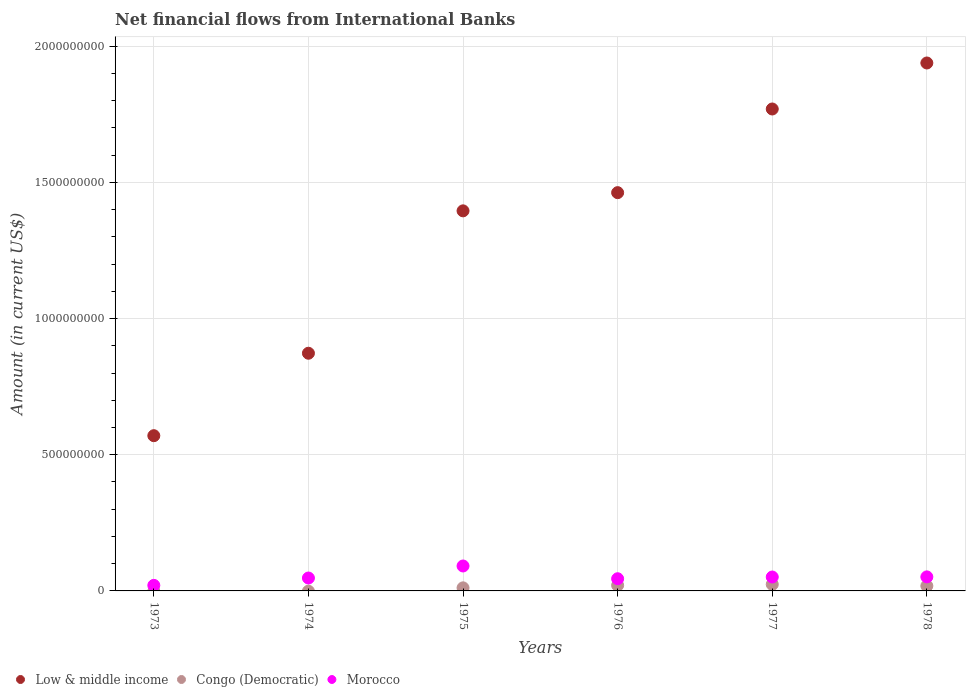Is the number of dotlines equal to the number of legend labels?
Make the answer very short. No. What is the net financial aid flows in Low & middle income in 1975?
Keep it short and to the point. 1.40e+09. Across all years, what is the maximum net financial aid flows in Low & middle income?
Keep it short and to the point. 1.94e+09. Across all years, what is the minimum net financial aid flows in Low & middle income?
Your response must be concise. 5.70e+08. In which year was the net financial aid flows in Morocco maximum?
Offer a very short reply. 1975. What is the total net financial aid flows in Congo (Democratic) in the graph?
Make the answer very short. 7.43e+07. What is the difference between the net financial aid flows in Morocco in 1974 and that in 1975?
Give a very brief answer. -4.42e+07. What is the difference between the net financial aid flows in Low & middle income in 1976 and the net financial aid flows in Congo (Democratic) in 1974?
Your answer should be very brief. 1.46e+09. What is the average net financial aid flows in Morocco per year?
Ensure brevity in your answer.  5.11e+07. In the year 1976, what is the difference between the net financial aid flows in Congo (Democratic) and net financial aid flows in Low & middle income?
Offer a terse response. -1.44e+09. In how many years, is the net financial aid flows in Low & middle income greater than 700000000 US$?
Keep it short and to the point. 5. What is the ratio of the net financial aid flows in Congo (Democratic) in 1975 to that in 1976?
Ensure brevity in your answer.  0.55. Is the net financial aid flows in Morocco in 1973 less than that in 1974?
Make the answer very short. Yes. Is the difference between the net financial aid flows in Congo (Democratic) in 1975 and 1977 greater than the difference between the net financial aid flows in Low & middle income in 1975 and 1977?
Your answer should be compact. Yes. What is the difference between the highest and the second highest net financial aid flows in Morocco?
Offer a very short reply. 4.00e+07. What is the difference between the highest and the lowest net financial aid flows in Morocco?
Your response must be concise. 7.12e+07. In how many years, is the net financial aid flows in Congo (Democratic) greater than the average net financial aid flows in Congo (Democratic) taken over all years?
Keep it short and to the point. 3. Is the sum of the net financial aid flows in Morocco in 1973 and 1977 greater than the maximum net financial aid flows in Low & middle income across all years?
Provide a short and direct response. No. Is the net financial aid flows in Congo (Democratic) strictly less than the net financial aid flows in Low & middle income over the years?
Give a very brief answer. Yes. How many years are there in the graph?
Keep it short and to the point. 6. What is the difference between two consecutive major ticks on the Y-axis?
Provide a short and direct response. 5.00e+08. Are the values on the major ticks of Y-axis written in scientific E-notation?
Offer a terse response. No. How are the legend labels stacked?
Your answer should be very brief. Horizontal. What is the title of the graph?
Offer a terse response. Net financial flows from International Banks. Does "Grenada" appear as one of the legend labels in the graph?
Keep it short and to the point. No. What is the label or title of the X-axis?
Provide a succinct answer. Years. What is the label or title of the Y-axis?
Provide a succinct answer. Amount (in current US$). What is the Amount (in current US$) of Low & middle income in 1973?
Offer a terse response. 5.70e+08. What is the Amount (in current US$) in Congo (Democratic) in 1973?
Your answer should be compact. 0. What is the Amount (in current US$) of Morocco in 1973?
Provide a succinct answer. 2.04e+07. What is the Amount (in current US$) of Low & middle income in 1974?
Make the answer very short. 8.73e+08. What is the Amount (in current US$) in Morocco in 1974?
Offer a terse response. 4.74e+07. What is the Amount (in current US$) of Low & middle income in 1975?
Keep it short and to the point. 1.40e+09. What is the Amount (in current US$) of Congo (Democratic) in 1975?
Your answer should be very brief. 1.13e+07. What is the Amount (in current US$) in Morocco in 1975?
Offer a terse response. 9.16e+07. What is the Amount (in current US$) of Low & middle income in 1976?
Your answer should be compact. 1.46e+09. What is the Amount (in current US$) of Congo (Democratic) in 1976?
Make the answer very short. 2.06e+07. What is the Amount (in current US$) of Morocco in 1976?
Offer a very short reply. 4.47e+07. What is the Amount (in current US$) in Low & middle income in 1977?
Offer a terse response. 1.77e+09. What is the Amount (in current US$) of Congo (Democratic) in 1977?
Offer a very short reply. 2.40e+07. What is the Amount (in current US$) in Morocco in 1977?
Provide a succinct answer. 5.11e+07. What is the Amount (in current US$) of Low & middle income in 1978?
Provide a short and direct response. 1.94e+09. What is the Amount (in current US$) of Congo (Democratic) in 1978?
Your response must be concise. 1.85e+07. What is the Amount (in current US$) of Morocco in 1978?
Keep it short and to the point. 5.15e+07. Across all years, what is the maximum Amount (in current US$) of Low & middle income?
Your answer should be compact. 1.94e+09. Across all years, what is the maximum Amount (in current US$) in Congo (Democratic)?
Keep it short and to the point. 2.40e+07. Across all years, what is the maximum Amount (in current US$) in Morocco?
Offer a very short reply. 9.16e+07. Across all years, what is the minimum Amount (in current US$) in Low & middle income?
Make the answer very short. 5.70e+08. Across all years, what is the minimum Amount (in current US$) in Congo (Democratic)?
Your response must be concise. 0. Across all years, what is the minimum Amount (in current US$) in Morocco?
Your answer should be compact. 2.04e+07. What is the total Amount (in current US$) in Low & middle income in the graph?
Provide a short and direct response. 8.01e+09. What is the total Amount (in current US$) in Congo (Democratic) in the graph?
Provide a succinct answer. 7.43e+07. What is the total Amount (in current US$) in Morocco in the graph?
Provide a short and direct response. 3.07e+08. What is the difference between the Amount (in current US$) of Low & middle income in 1973 and that in 1974?
Provide a short and direct response. -3.03e+08. What is the difference between the Amount (in current US$) of Morocco in 1973 and that in 1974?
Make the answer very short. -2.70e+07. What is the difference between the Amount (in current US$) in Low & middle income in 1973 and that in 1975?
Offer a very short reply. -8.26e+08. What is the difference between the Amount (in current US$) of Morocco in 1973 and that in 1975?
Offer a very short reply. -7.12e+07. What is the difference between the Amount (in current US$) of Low & middle income in 1973 and that in 1976?
Give a very brief answer. -8.92e+08. What is the difference between the Amount (in current US$) in Morocco in 1973 and that in 1976?
Keep it short and to the point. -2.43e+07. What is the difference between the Amount (in current US$) of Low & middle income in 1973 and that in 1977?
Ensure brevity in your answer.  -1.20e+09. What is the difference between the Amount (in current US$) of Morocco in 1973 and that in 1977?
Ensure brevity in your answer.  -3.07e+07. What is the difference between the Amount (in current US$) of Low & middle income in 1973 and that in 1978?
Provide a succinct answer. -1.37e+09. What is the difference between the Amount (in current US$) in Morocco in 1973 and that in 1978?
Offer a terse response. -3.11e+07. What is the difference between the Amount (in current US$) in Low & middle income in 1974 and that in 1975?
Ensure brevity in your answer.  -5.23e+08. What is the difference between the Amount (in current US$) of Morocco in 1974 and that in 1975?
Keep it short and to the point. -4.42e+07. What is the difference between the Amount (in current US$) in Low & middle income in 1974 and that in 1976?
Provide a succinct answer. -5.90e+08. What is the difference between the Amount (in current US$) in Morocco in 1974 and that in 1976?
Your answer should be very brief. 2.64e+06. What is the difference between the Amount (in current US$) of Low & middle income in 1974 and that in 1977?
Ensure brevity in your answer.  -8.97e+08. What is the difference between the Amount (in current US$) of Morocco in 1974 and that in 1977?
Keep it short and to the point. -3.71e+06. What is the difference between the Amount (in current US$) in Low & middle income in 1974 and that in 1978?
Give a very brief answer. -1.07e+09. What is the difference between the Amount (in current US$) of Morocco in 1974 and that in 1978?
Offer a terse response. -4.17e+06. What is the difference between the Amount (in current US$) of Low & middle income in 1975 and that in 1976?
Your response must be concise. -6.68e+07. What is the difference between the Amount (in current US$) in Congo (Democratic) in 1975 and that in 1976?
Your answer should be very brief. -9.30e+06. What is the difference between the Amount (in current US$) in Morocco in 1975 and that in 1976?
Your answer should be very brief. 4.68e+07. What is the difference between the Amount (in current US$) of Low & middle income in 1975 and that in 1977?
Keep it short and to the point. -3.74e+08. What is the difference between the Amount (in current US$) of Congo (Democratic) in 1975 and that in 1977?
Offer a terse response. -1.27e+07. What is the difference between the Amount (in current US$) of Morocco in 1975 and that in 1977?
Your response must be concise. 4.05e+07. What is the difference between the Amount (in current US$) in Low & middle income in 1975 and that in 1978?
Make the answer very short. -5.43e+08. What is the difference between the Amount (in current US$) in Congo (Democratic) in 1975 and that in 1978?
Ensure brevity in your answer.  -7.18e+06. What is the difference between the Amount (in current US$) of Morocco in 1975 and that in 1978?
Provide a succinct answer. 4.00e+07. What is the difference between the Amount (in current US$) of Low & middle income in 1976 and that in 1977?
Your answer should be very brief. -3.07e+08. What is the difference between the Amount (in current US$) in Congo (Democratic) in 1976 and that in 1977?
Your response must be concise. -3.41e+06. What is the difference between the Amount (in current US$) of Morocco in 1976 and that in 1977?
Your answer should be very brief. -6.35e+06. What is the difference between the Amount (in current US$) in Low & middle income in 1976 and that in 1978?
Provide a short and direct response. -4.76e+08. What is the difference between the Amount (in current US$) of Congo (Democratic) in 1976 and that in 1978?
Provide a succinct answer. 2.12e+06. What is the difference between the Amount (in current US$) in Morocco in 1976 and that in 1978?
Your answer should be compact. -6.81e+06. What is the difference between the Amount (in current US$) in Low & middle income in 1977 and that in 1978?
Offer a terse response. -1.69e+08. What is the difference between the Amount (in current US$) of Congo (Democratic) in 1977 and that in 1978?
Keep it short and to the point. 5.53e+06. What is the difference between the Amount (in current US$) of Morocco in 1977 and that in 1978?
Provide a short and direct response. -4.62e+05. What is the difference between the Amount (in current US$) of Low & middle income in 1973 and the Amount (in current US$) of Morocco in 1974?
Your answer should be compact. 5.23e+08. What is the difference between the Amount (in current US$) in Low & middle income in 1973 and the Amount (in current US$) in Congo (Democratic) in 1975?
Give a very brief answer. 5.59e+08. What is the difference between the Amount (in current US$) of Low & middle income in 1973 and the Amount (in current US$) of Morocco in 1975?
Provide a succinct answer. 4.78e+08. What is the difference between the Amount (in current US$) of Low & middle income in 1973 and the Amount (in current US$) of Congo (Democratic) in 1976?
Your response must be concise. 5.49e+08. What is the difference between the Amount (in current US$) of Low & middle income in 1973 and the Amount (in current US$) of Morocco in 1976?
Your response must be concise. 5.25e+08. What is the difference between the Amount (in current US$) in Low & middle income in 1973 and the Amount (in current US$) in Congo (Democratic) in 1977?
Provide a short and direct response. 5.46e+08. What is the difference between the Amount (in current US$) of Low & middle income in 1973 and the Amount (in current US$) of Morocco in 1977?
Your answer should be compact. 5.19e+08. What is the difference between the Amount (in current US$) in Low & middle income in 1973 and the Amount (in current US$) in Congo (Democratic) in 1978?
Offer a terse response. 5.52e+08. What is the difference between the Amount (in current US$) in Low & middle income in 1973 and the Amount (in current US$) in Morocco in 1978?
Your response must be concise. 5.18e+08. What is the difference between the Amount (in current US$) in Low & middle income in 1974 and the Amount (in current US$) in Congo (Democratic) in 1975?
Your response must be concise. 8.61e+08. What is the difference between the Amount (in current US$) in Low & middle income in 1974 and the Amount (in current US$) in Morocco in 1975?
Make the answer very short. 7.81e+08. What is the difference between the Amount (in current US$) in Low & middle income in 1974 and the Amount (in current US$) in Congo (Democratic) in 1976?
Offer a very short reply. 8.52e+08. What is the difference between the Amount (in current US$) of Low & middle income in 1974 and the Amount (in current US$) of Morocco in 1976?
Offer a very short reply. 8.28e+08. What is the difference between the Amount (in current US$) of Low & middle income in 1974 and the Amount (in current US$) of Congo (Democratic) in 1977?
Your answer should be very brief. 8.49e+08. What is the difference between the Amount (in current US$) in Low & middle income in 1974 and the Amount (in current US$) in Morocco in 1977?
Provide a short and direct response. 8.22e+08. What is the difference between the Amount (in current US$) of Low & middle income in 1974 and the Amount (in current US$) of Congo (Democratic) in 1978?
Provide a succinct answer. 8.54e+08. What is the difference between the Amount (in current US$) in Low & middle income in 1974 and the Amount (in current US$) in Morocco in 1978?
Your answer should be very brief. 8.21e+08. What is the difference between the Amount (in current US$) of Low & middle income in 1975 and the Amount (in current US$) of Congo (Democratic) in 1976?
Provide a short and direct response. 1.37e+09. What is the difference between the Amount (in current US$) of Low & middle income in 1975 and the Amount (in current US$) of Morocco in 1976?
Your response must be concise. 1.35e+09. What is the difference between the Amount (in current US$) in Congo (Democratic) in 1975 and the Amount (in current US$) in Morocco in 1976?
Your answer should be very brief. -3.34e+07. What is the difference between the Amount (in current US$) in Low & middle income in 1975 and the Amount (in current US$) in Congo (Democratic) in 1977?
Offer a very short reply. 1.37e+09. What is the difference between the Amount (in current US$) in Low & middle income in 1975 and the Amount (in current US$) in Morocco in 1977?
Keep it short and to the point. 1.34e+09. What is the difference between the Amount (in current US$) of Congo (Democratic) in 1975 and the Amount (in current US$) of Morocco in 1977?
Offer a very short reply. -3.98e+07. What is the difference between the Amount (in current US$) in Low & middle income in 1975 and the Amount (in current US$) in Congo (Democratic) in 1978?
Make the answer very short. 1.38e+09. What is the difference between the Amount (in current US$) in Low & middle income in 1975 and the Amount (in current US$) in Morocco in 1978?
Provide a succinct answer. 1.34e+09. What is the difference between the Amount (in current US$) in Congo (Democratic) in 1975 and the Amount (in current US$) in Morocco in 1978?
Provide a short and direct response. -4.02e+07. What is the difference between the Amount (in current US$) in Low & middle income in 1976 and the Amount (in current US$) in Congo (Democratic) in 1977?
Keep it short and to the point. 1.44e+09. What is the difference between the Amount (in current US$) of Low & middle income in 1976 and the Amount (in current US$) of Morocco in 1977?
Your answer should be very brief. 1.41e+09. What is the difference between the Amount (in current US$) in Congo (Democratic) in 1976 and the Amount (in current US$) in Morocco in 1977?
Offer a very short reply. -3.05e+07. What is the difference between the Amount (in current US$) in Low & middle income in 1976 and the Amount (in current US$) in Congo (Democratic) in 1978?
Make the answer very short. 1.44e+09. What is the difference between the Amount (in current US$) in Low & middle income in 1976 and the Amount (in current US$) in Morocco in 1978?
Your answer should be compact. 1.41e+09. What is the difference between the Amount (in current US$) of Congo (Democratic) in 1976 and the Amount (in current US$) of Morocco in 1978?
Your answer should be compact. -3.09e+07. What is the difference between the Amount (in current US$) in Low & middle income in 1977 and the Amount (in current US$) in Congo (Democratic) in 1978?
Your response must be concise. 1.75e+09. What is the difference between the Amount (in current US$) in Low & middle income in 1977 and the Amount (in current US$) in Morocco in 1978?
Offer a very short reply. 1.72e+09. What is the difference between the Amount (in current US$) in Congo (Democratic) in 1977 and the Amount (in current US$) in Morocco in 1978?
Give a very brief answer. -2.75e+07. What is the average Amount (in current US$) of Low & middle income per year?
Provide a short and direct response. 1.33e+09. What is the average Amount (in current US$) in Congo (Democratic) per year?
Provide a succinct answer. 1.24e+07. What is the average Amount (in current US$) of Morocco per year?
Keep it short and to the point. 5.11e+07. In the year 1973, what is the difference between the Amount (in current US$) in Low & middle income and Amount (in current US$) in Morocco?
Offer a terse response. 5.50e+08. In the year 1974, what is the difference between the Amount (in current US$) of Low & middle income and Amount (in current US$) of Morocco?
Provide a succinct answer. 8.25e+08. In the year 1975, what is the difference between the Amount (in current US$) of Low & middle income and Amount (in current US$) of Congo (Democratic)?
Provide a succinct answer. 1.38e+09. In the year 1975, what is the difference between the Amount (in current US$) of Low & middle income and Amount (in current US$) of Morocco?
Make the answer very short. 1.30e+09. In the year 1975, what is the difference between the Amount (in current US$) of Congo (Democratic) and Amount (in current US$) of Morocco?
Provide a short and direct response. -8.03e+07. In the year 1976, what is the difference between the Amount (in current US$) in Low & middle income and Amount (in current US$) in Congo (Democratic)?
Ensure brevity in your answer.  1.44e+09. In the year 1976, what is the difference between the Amount (in current US$) of Low & middle income and Amount (in current US$) of Morocco?
Provide a short and direct response. 1.42e+09. In the year 1976, what is the difference between the Amount (in current US$) in Congo (Democratic) and Amount (in current US$) in Morocco?
Keep it short and to the point. -2.41e+07. In the year 1977, what is the difference between the Amount (in current US$) of Low & middle income and Amount (in current US$) of Congo (Democratic)?
Provide a short and direct response. 1.75e+09. In the year 1977, what is the difference between the Amount (in current US$) of Low & middle income and Amount (in current US$) of Morocco?
Your answer should be very brief. 1.72e+09. In the year 1977, what is the difference between the Amount (in current US$) of Congo (Democratic) and Amount (in current US$) of Morocco?
Give a very brief answer. -2.71e+07. In the year 1978, what is the difference between the Amount (in current US$) in Low & middle income and Amount (in current US$) in Congo (Democratic)?
Your answer should be compact. 1.92e+09. In the year 1978, what is the difference between the Amount (in current US$) of Low & middle income and Amount (in current US$) of Morocco?
Offer a very short reply. 1.89e+09. In the year 1978, what is the difference between the Amount (in current US$) of Congo (Democratic) and Amount (in current US$) of Morocco?
Make the answer very short. -3.31e+07. What is the ratio of the Amount (in current US$) of Low & middle income in 1973 to that in 1974?
Your response must be concise. 0.65. What is the ratio of the Amount (in current US$) in Morocco in 1973 to that in 1974?
Make the answer very short. 0.43. What is the ratio of the Amount (in current US$) of Low & middle income in 1973 to that in 1975?
Keep it short and to the point. 0.41. What is the ratio of the Amount (in current US$) of Morocco in 1973 to that in 1975?
Offer a very short reply. 0.22. What is the ratio of the Amount (in current US$) in Low & middle income in 1973 to that in 1976?
Offer a very short reply. 0.39. What is the ratio of the Amount (in current US$) of Morocco in 1973 to that in 1976?
Provide a succinct answer. 0.46. What is the ratio of the Amount (in current US$) in Low & middle income in 1973 to that in 1977?
Keep it short and to the point. 0.32. What is the ratio of the Amount (in current US$) in Morocco in 1973 to that in 1977?
Give a very brief answer. 0.4. What is the ratio of the Amount (in current US$) of Low & middle income in 1973 to that in 1978?
Keep it short and to the point. 0.29. What is the ratio of the Amount (in current US$) of Morocco in 1973 to that in 1978?
Your response must be concise. 0.4. What is the ratio of the Amount (in current US$) in Low & middle income in 1974 to that in 1975?
Ensure brevity in your answer.  0.63. What is the ratio of the Amount (in current US$) in Morocco in 1974 to that in 1975?
Your response must be concise. 0.52. What is the ratio of the Amount (in current US$) of Low & middle income in 1974 to that in 1976?
Ensure brevity in your answer.  0.6. What is the ratio of the Amount (in current US$) in Morocco in 1974 to that in 1976?
Provide a short and direct response. 1.06. What is the ratio of the Amount (in current US$) in Low & middle income in 1974 to that in 1977?
Offer a terse response. 0.49. What is the ratio of the Amount (in current US$) of Morocco in 1974 to that in 1977?
Offer a very short reply. 0.93. What is the ratio of the Amount (in current US$) of Low & middle income in 1974 to that in 1978?
Ensure brevity in your answer.  0.45. What is the ratio of the Amount (in current US$) of Morocco in 1974 to that in 1978?
Offer a very short reply. 0.92. What is the ratio of the Amount (in current US$) of Low & middle income in 1975 to that in 1976?
Offer a terse response. 0.95. What is the ratio of the Amount (in current US$) of Congo (Democratic) in 1975 to that in 1976?
Offer a terse response. 0.55. What is the ratio of the Amount (in current US$) of Morocco in 1975 to that in 1976?
Keep it short and to the point. 2.05. What is the ratio of the Amount (in current US$) in Low & middle income in 1975 to that in 1977?
Your answer should be very brief. 0.79. What is the ratio of the Amount (in current US$) of Congo (Democratic) in 1975 to that in 1977?
Offer a very short reply. 0.47. What is the ratio of the Amount (in current US$) in Morocco in 1975 to that in 1977?
Keep it short and to the point. 1.79. What is the ratio of the Amount (in current US$) in Low & middle income in 1975 to that in 1978?
Your answer should be compact. 0.72. What is the ratio of the Amount (in current US$) in Congo (Democratic) in 1975 to that in 1978?
Provide a short and direct response. 0.61. What is the ratio of the Amount (in current US$) of Morocco in 1975 to that in 1978?
Offer a terse response. 1.78. What is the ratio of the Amount (in current US$) of Low & middle income in 1976 to that in 1977?
Give a very brief answer. 0.83. What is the ratio of the Amount (in current US$) of Congo (Democratic) in 1976 to that in 1977?
Keep it short and to the point. 0.86. What is the ratio of the Amount (in current US$) of Morocco in 1976 to that in 1977?
Keep it short and to the point. 0.88. What is the ratio of the Amount (in current US$) of Low & middle income in 1976 to that in 1978?
Give a very brief answer. 0.75. What is the ratio of the Amount (in current US$) of Congo (Democratic) in 1976 to that in 1978?
Keep it short and to the point. 1.11. What is the ratio of the Amount (in current US$) in Morocco in 1976 to that in 1978?
Give a very brief answer. 0.87. What is the ratio of the Amount (in current US$) in Low & middle income in 1977 to that in 1978?
Give a very brief answer. 0.91. What is the ratio of the Amount (in current US$) of Congo (Democratic) in 1977 to that in 1978?
Keep it short and to the point. 1.3. What is the ratio of the Amount (in current US$) of Morocco in 1977 to that in 1978?
Your answer should be very brief. 0.99. What is the difference between the highest and the second highest Amount (in current US$) in Low & middle income?
Provide a short and direct response. 1.69e+08. What is the difference between the highest and the second highest Amount (in current US$) of Congo (Democratic)?
Make the answer very short. 3.41e+06. What is the difference between the highest and the second highest Amount (in current US$) in Morocco?
Provide a succinct answer. 4.00e+07. What is the difference between the highest and the lowest Amount (in current US$) of Low & middle income?
Make the answer very short. 1.37e+09. What is the difference between the highest and the lowest Amount (in current US$) in Congo (Democratic)?
Ensure brevity in your answer.  2.40e+07. What is the difference between the highest and the lowest Amount (in current US$) of Morocco?
Make the answer very short. 7.12e+07. 